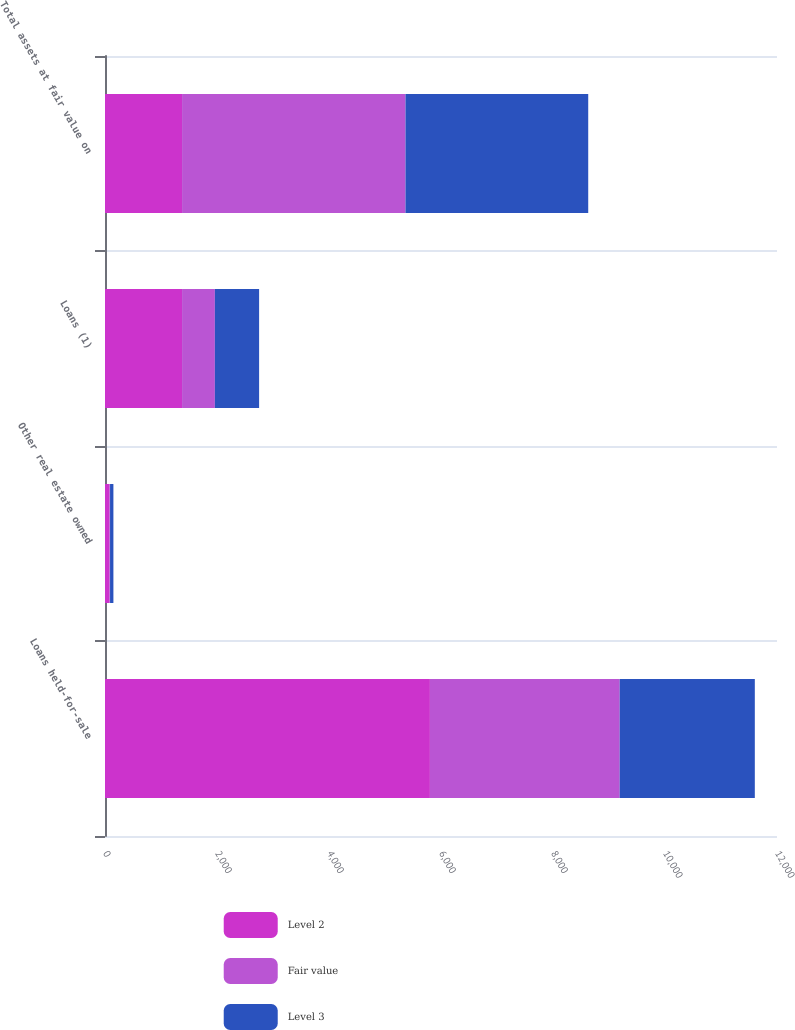Convert chart to OTSL. <chart><loc_0><loc_0><loc_500><loc_500><stacked_bar_chart><ecel><fcel>Loans held-for-sale<fcel>Other real estate owned<fcel>Loans (1)<fcel>Total assets at fair value on<nl><fcel>Level 2<fcel>5802<fcel>75<fcel>1376<fcel>1376<nl><fcel>Fair value<fcel>3389<fcel>15<fcel>586<fcel>3990<nl><fcel>Level 3<fcel>2413<fcel>60<fcel>790<fcel>3263<nl></chart> 